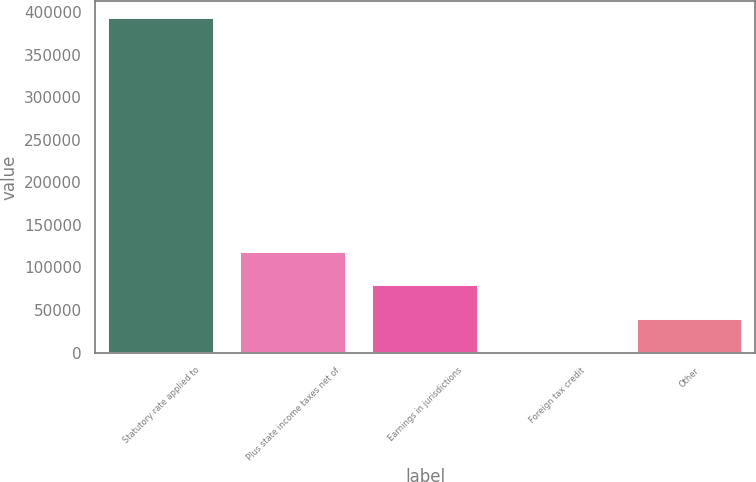<chart> <loc_0><loc_0><loc_500><loc_500><bar_chart><fcel>Statutory rate applied to<fcel>Plus state income taxes net of<fcel>Earnings in jurisdictions<fcel>Foreign tax credit<fcel>Other<nl><fcel>393288<fcel>118171<fcel>78868.8<fcel>264<fcel>39566.4<nl></chart> 